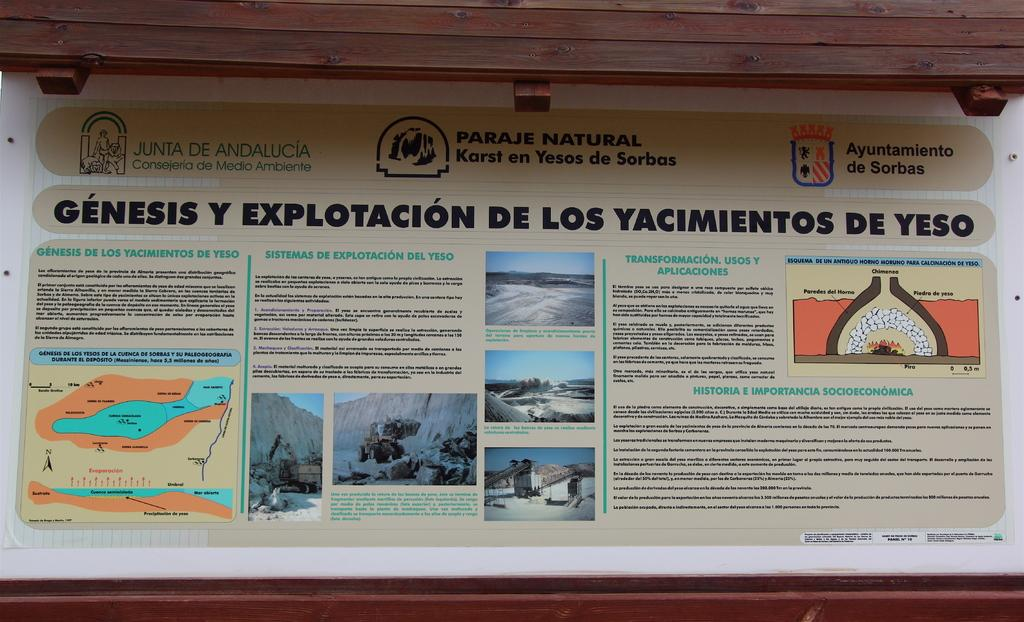Provide a one-sentence caption for the provided image. An information pamphlet that says Genesis Explotacion De Los Yacimientos De Yeso on it. 